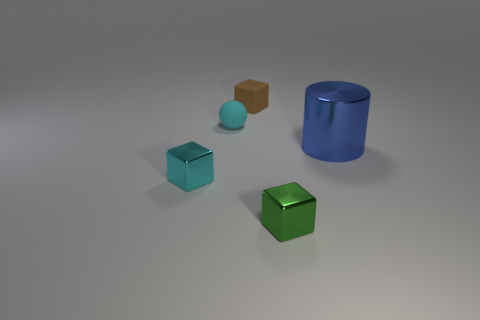What shadows are visible in the image, and what can they tell us about the lighting? The shadows cast by the objects are soft and diffuse, indicating that the light source, likely artificial, is not extremely close but provides enough illumination to clearly differentiate the objects. It looks like there's a single overhead light source because the shadows are mostly oriented in the same direction. Does the softness of the shadows affect how the objects are perceived? Definitely. The soft shadows help give a sense of the three-dimensional form of the objects, lending a feeling of depth and space within the image. If the shadows were harder, they might create a more dramatic effect but could also make the scene look more harsh and contrasted. 